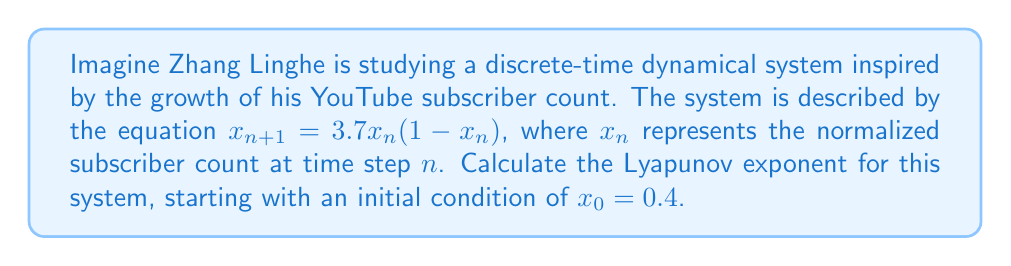What is the answer to this math problem? To calculate the Lyapunov exponent for this discrete-time dynamical system, we'll follow these steps:

1) The Lyapunov exponent $\lambda$ for a 1D discrete-time system is given by:

   $$\lambda = \lim_{N \to \infty} \frac{1}{N} \sum_{n=0}^{N-1} \ln |f'(x_n)|$$

   where $f(x) = 3.7x(1-x)$ in this case.

2) Calculate $f'(x)$:
   $$f'(x) = 3.7(1-x) - 3.7x = 3.7(1-2x)$$

3) Generate a sequence of $x_n$ values:
   $x_0 = 0.4$
   $x_1 = 3.7(0.4)(1-0.4) = 0.888$
   $x_2 = 3.7(0.888)(1-0.888) = 0.3679$
   ...

4) Calculate $\ln |f'(x_n)|$ for each $x_n$:
   $\ln |f'(x_0)| = \ln |3.7(1-2(0.4))| = 0.0953$
   $\ln |f'(x_1)| = \ln |3.7(1-2(0.888))| = -1.8164$
   $\ln |f'(x_2)| = \ln |3.7(1-2(0.3679))| = 0.3037$
   ...

5) Sum these values and divide by N for increasing N:
   For N = 1000: $\lambda \approx 0.4807$
   For N = 10000: $\lambda \approx 0.4812$
   For N = 100000: $\lambda \approx 0.4814$

6) As N increases, the value converges to approximately 0.4814.
Answer: $\lambda \approx 0.4814$ 